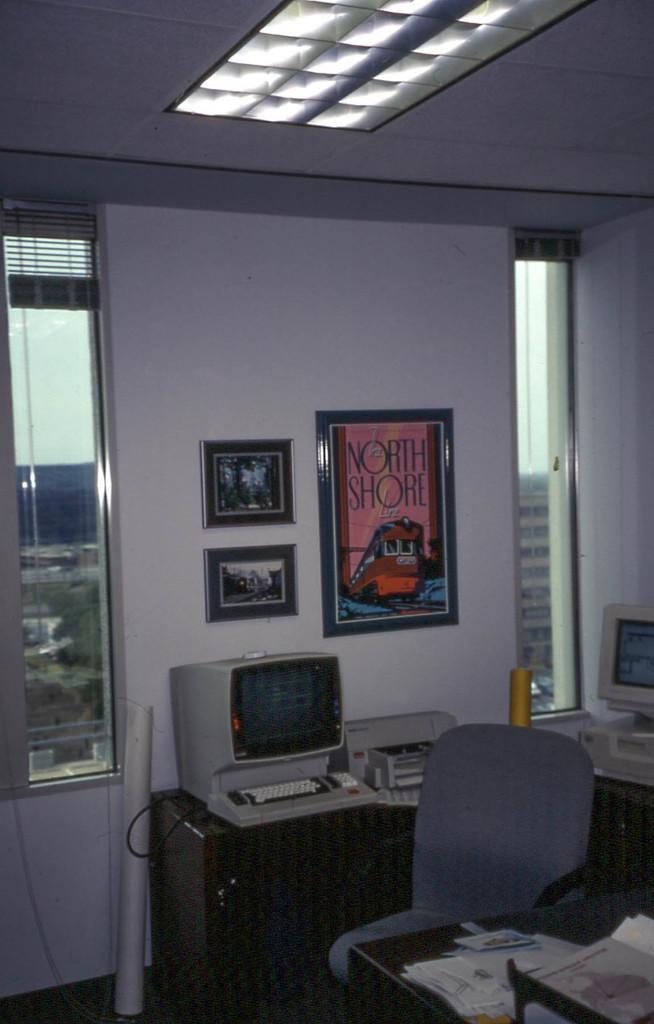<image>
Provide a brief description of the given image. An old office setting with a North Shore framed poster on the wall. 